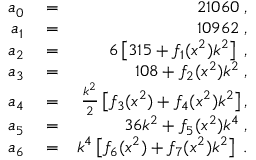<formula> <loc_0><loc_0><loc_500><loc_500>\begin{array} { r l r } { a _ { 0 } } & = } & { 2 1 0 6 0 \, , } \\ { a _ { 1 } } & = } & { 1 0 9 6 2 \, , } \\ { a _ { 2 } } & = } & { 6 \left [ 3 1 5 + f _ { 1 } ( x ^ { 2 } ) k ^ { 2 } \right ] \, , } \\ { a _ { 3 } } & = } & { 1 0 8 + f _ { 2 } ( x ^ { 2 } ) k ^ { 2 } \, , } \\ { a _ { 4 } } & = } & { \frac { k ^ { 2 } } { 2 } \left [ f _ { 3 } ( x ^ { 2 } ) + f _ { 4 } ( x ^ { 2 } ) k ^ { 2 } \right ] , } \\ { a _ { 5 } } & = } & { 3 6 k ^ { 2 } + f _ { 5 } ( x ^ { 2 } ) k ^ { 4 } \, , } \\ { a _ { 6 } } & = } & { k ^ { 4 } \left [ f _ { 6 } ( x ^ { 2 } ) + f _ { 7 } ( x ^ { 2 } ) k ^ { 2 } \right ] \, . } \end{array}</formula> 